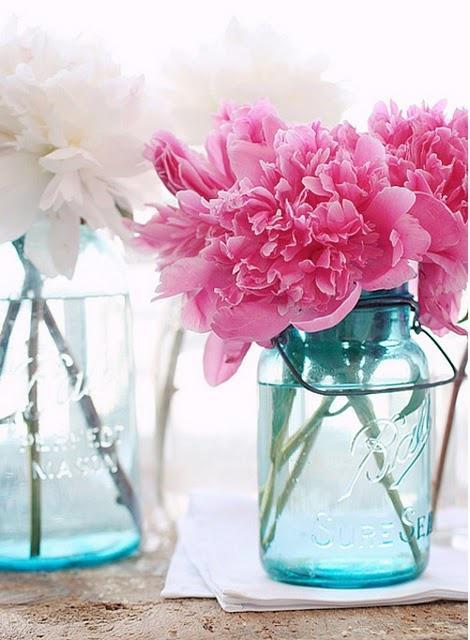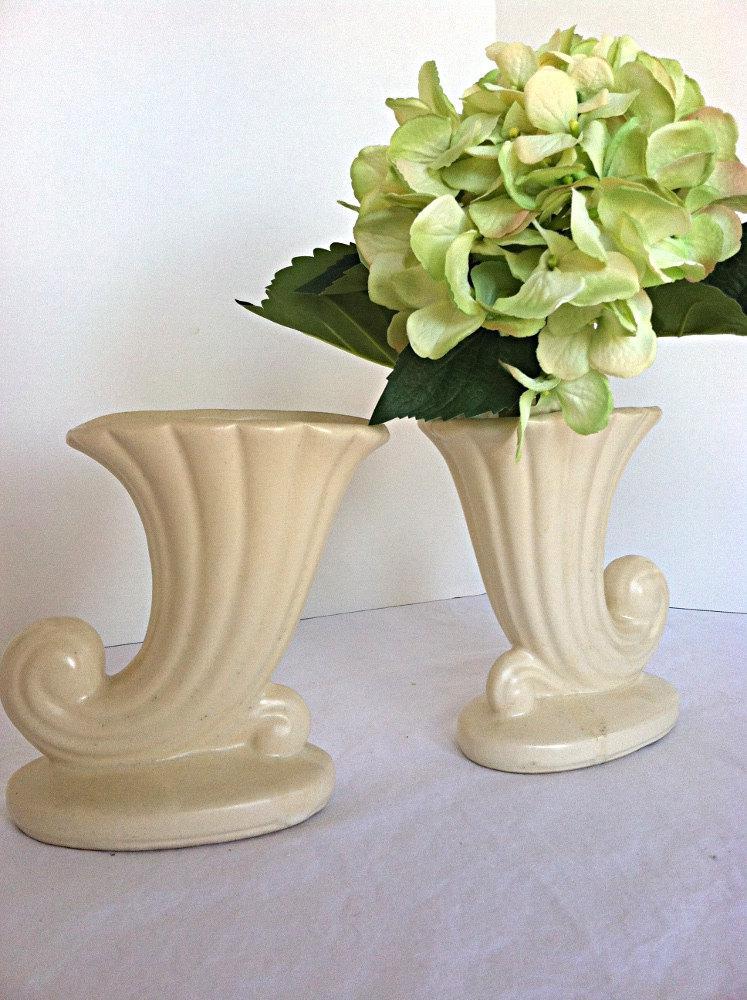The first image is the image on the left, the second image is the image on the right. Considering the images on both sides, is "None of the vases contain flowers." valid? Answer yes or no. No. The first image is the image on the left, the second image is the image on the right. Considering the images on both sides, is "None of the vases have flowers inserted into them." valid? Answer yes or no. No. 